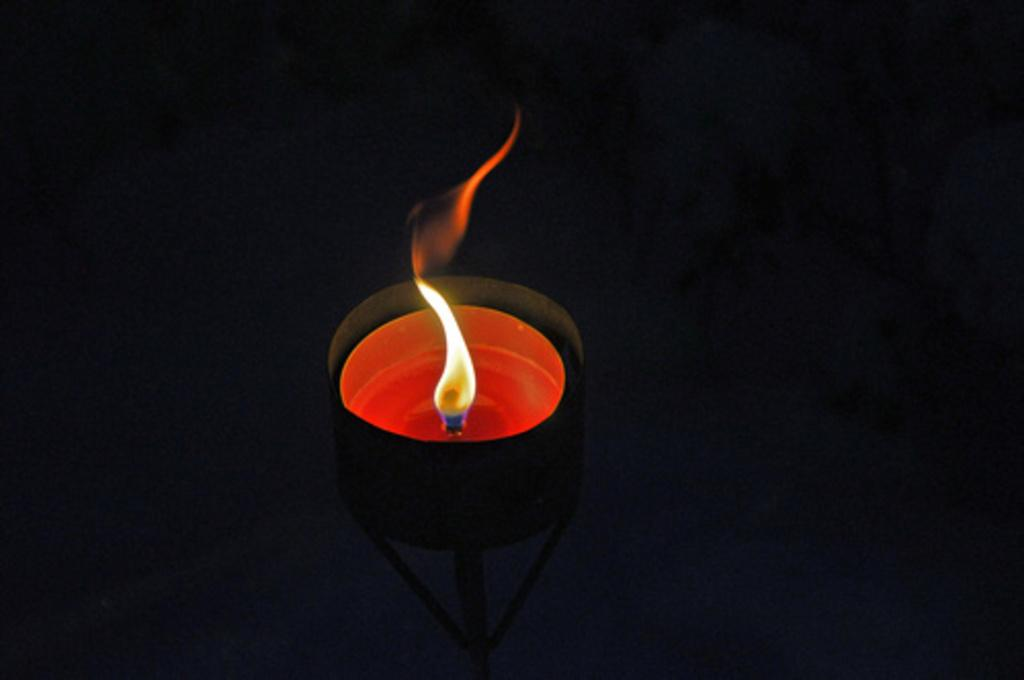What object is the main focus of the image? There is a candle in the image. What is the state of the candle? The candle is lighted. How is the candle positioned in the image? The candle is placed on a candle stand. What can be inferred about the lighting conditions in the image? The background of the image is black, and it was taken in a dark environment. What type of shade is covering the candle in the image? There is no shade covering the candle in the image; it is lighted and placed on a candle stand. What caption would you give to the image? The provided facts do not include any information about a caption, so it cannot be determined from the image. 